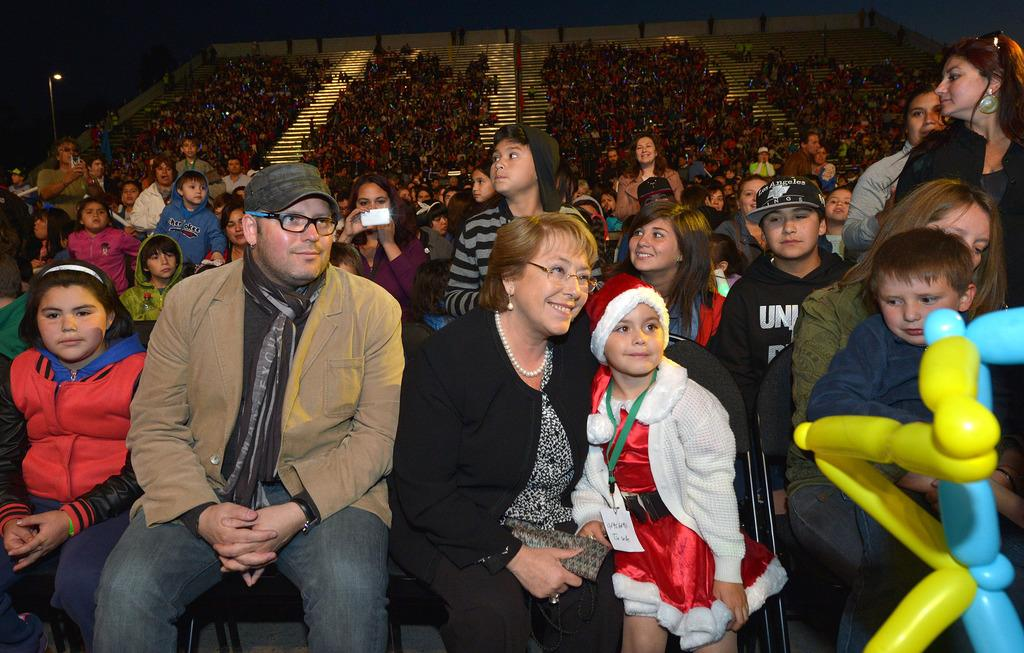What are the people in the center of the image doing? The people in the center of the image are sitting on chairs. Can you describe the people in the background of the image? The people in the background of the image are sitting in stands. What type of meal is being served to the people in the image? There is no meal present in the image; it only shows people sitting on chairs and in stands. What grade does the pipe receive in the image? There is no pipe present in the image, so it cannot be graded. 